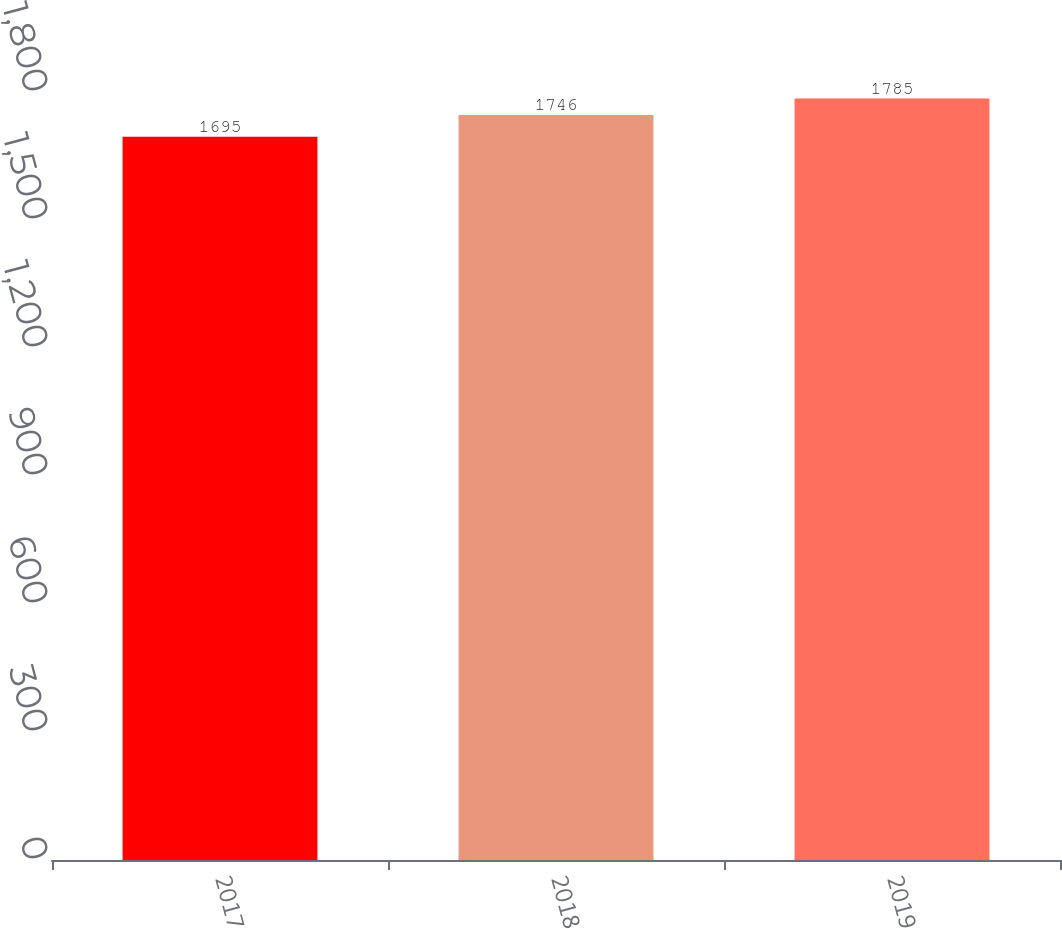Convert chart to OTSL. <chart><loc_0><loc_0><loc_500><loc_500><bar_chart><fcel>2017<fcel>2018<fcel>2019<nl><fcel>1695<fcel>1746<fcel>1785<nl></chart> 